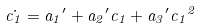<formula> <loc_0><loc_0><loc_500><loc_500>\dot { c _ { 1 } } = { a _ { 1 } } ^ { \prime } + { a _ { 2 } } ^ { \prime } c _ { 1 } + { a _ { 3 } } ^ { \prime } { c _ { 1 } } ^ { 2 }</formula> 